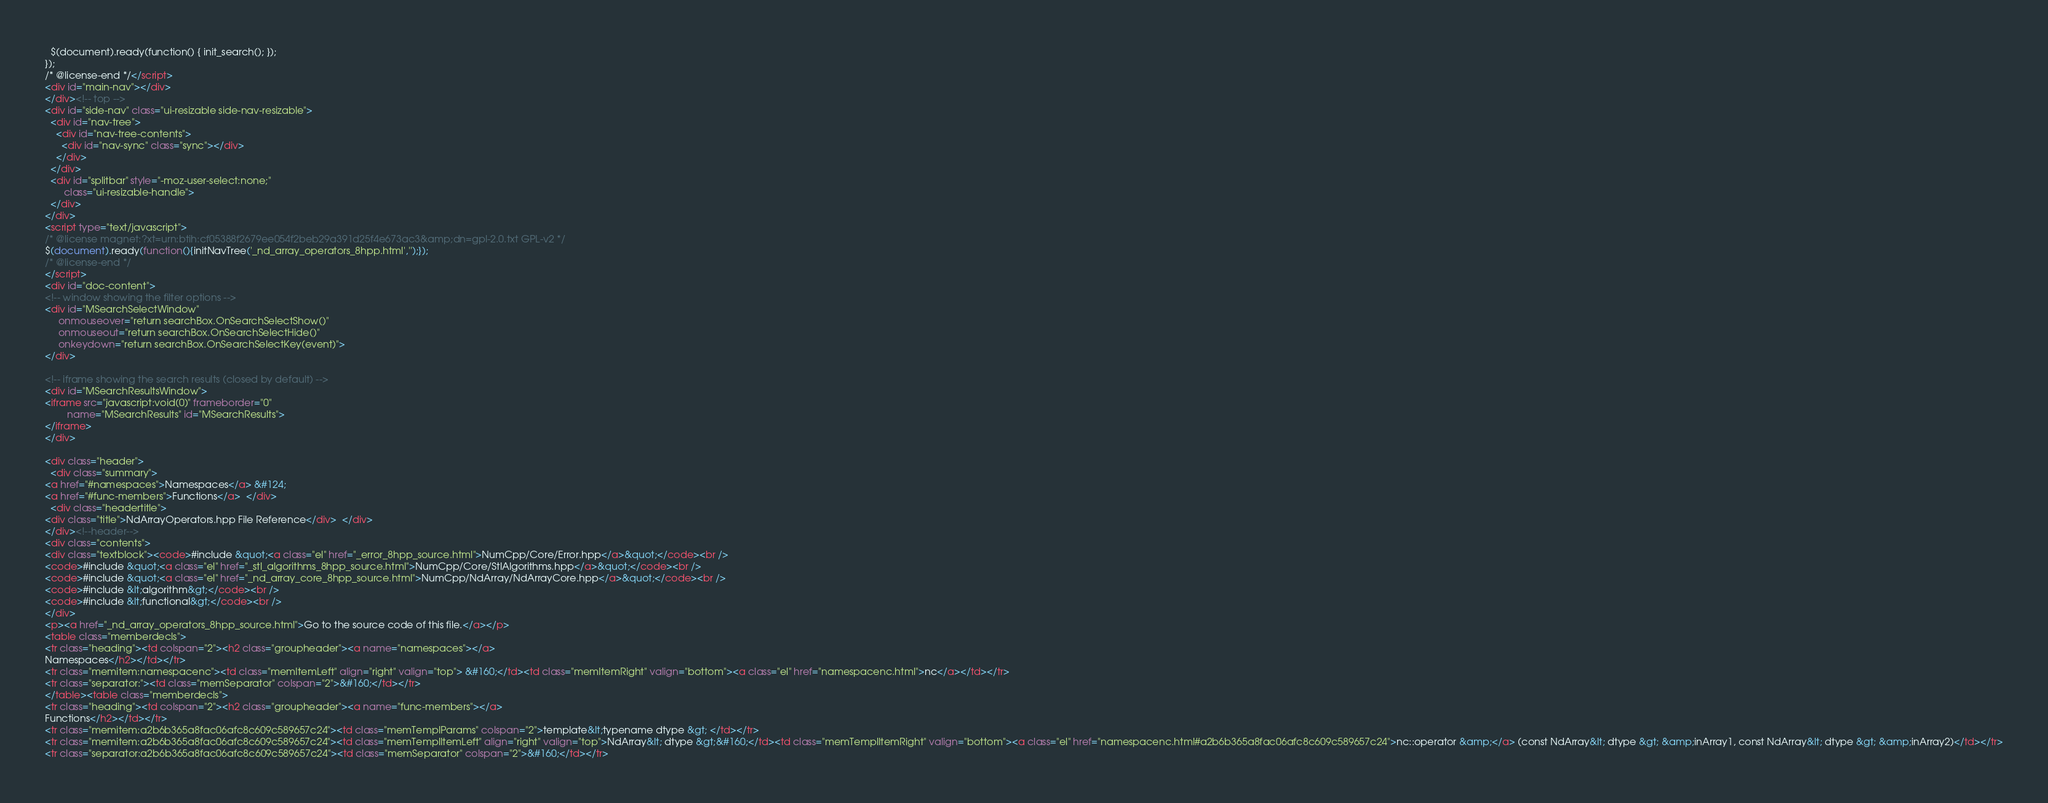Convert code to text. <code><loc_0><loc_0><loc_500><loc_500><_HTML_>  $(document).ready(function() { init_search(); });
});
/* @license-end */</script>
<div id="main-nav"></div>
</div><!-- top -->
<div id="side-nav" class="ui-resizable side-nav-resizable">
  <div id="nav-tree">
    <div id="nav-tree-contents">
      <div id="nav-sync" class="sync"></div>
    </div>
  </div>
  <div id="splitbar" style="-moz-user-select:none;" 
       class="ui-resizable-handle">
  </div>
</div>
<script type="text/javascript">
/* @license magnet:?xt=urn:btih:cf05388f2679ee054f2beb29a391d25f4e673ac3&amp;dn=gpl-2.0.txt GPL-v2 */
$(document).ready(function(){initNavTree('_nd_array_operators_8hpp.html','');});
/* @license-end */
</script>
<div id="doc-content">
<!-- window showing the filter options -->
<div id="MSearchSelectWindow"
     onmouseover="return searchBox.OnSearchSelectShow()"
     onmouseout="return searchBox.OnSearchSelectHide()"
     onkeydown="return searchBox.OnSearchSelectKey(event)">
</div>

<!-- iframe showing the search results (closed by default) -->
<div id="MSearchResultsWindow">
<iframe src="javascript:void(0)" frameborder="0" 
        name="MSearchResults" id="MSearchResults">
</iframe>
</div>

<div class="header">
  <div class="summary">
<a href="#namespaces">Namespaces</a> &#124;
<a href="#func-members">Functions</a>  </div>
  <div class="headertitle">
<div class="title">NdArrayOperators.hpp File Reference</div>  </div>
</div><!--header-->
<div class="contents">
<div class="textblock"><code>#include &quot;<a class="el" href="_error_8hpp_source.html">NumCpp/Core/Error.hpp</a>&quot;</code><br />
<code>#include &quot;<a class="el" href="_stl_algorithms_8hpp_source.html">NumCpp/Core/StlAlgorithms.hpp</a>&quot;</code><br />
<code>#include &quot;<a class="el" href="_nd_array_core_8hpp_source.html">NumCpp/NdArray/NdArrayCore.hpp</a>&quot;</code><br />
<code>#include &lt;algorithm&gt;</code><br />
<code>#include &lt;functional&gt;</code><br />
</div>
<p><a href="_nd_array_operators_8hpp_source.html">Go to the source code of this file.</a></p>
<table class="memberdecls">
<tr class="heading"><td colspan="2"><h2 class="groupheader"><a name="namespaces"></a>
Namespaces</h2></td></tr>
<tr class="memitem:namespacenc"><td class="memItemLeft" align="right" valign="top"> &#160;</td><td class="memItemRight" valign="bottom"><a class="el" href="namespacenc.html">nc</a></td></tr>
<tr class="separator:"><td class="memSeparator" colspan="2">&#160;</td></tr>
</table><table class="memberdecls">
<tr class="heading"><td colspan="2"><h2 class="groupheader"><a name="func-members"></a>
Functions</h2></td></tr>
<tr class="memitem:a2b6b365a8fac06afc8c609c589657c24"><td class="memTemplParams" colspan="2">template&lt;typename dtype &gt; </td></tr>
<tr class="memitem:a2b6b365a8fac06afc8c609c589657c24"><td class="memTemplItemLeft" align="right" valign="top">NdArray&lt; dtype &gt;&#160;</td><td class="memTemplItemRight" valign="bottom"><a class="el" href="namespacenc.html#a2b6b365a8fac06afc8c609c589657c24">nc::operator &amp;</a> (const NdArray&lt; dtype &gt; &amp;inArray1, const NdArray&lt; dtype &gt; &amp;inArray2)</td></tr>
<tr class="separator:a2b6b365a8fac06afc8c609c589657c24"><td class="memSeparator" colspan="2">&#160;</td></tr></code> 